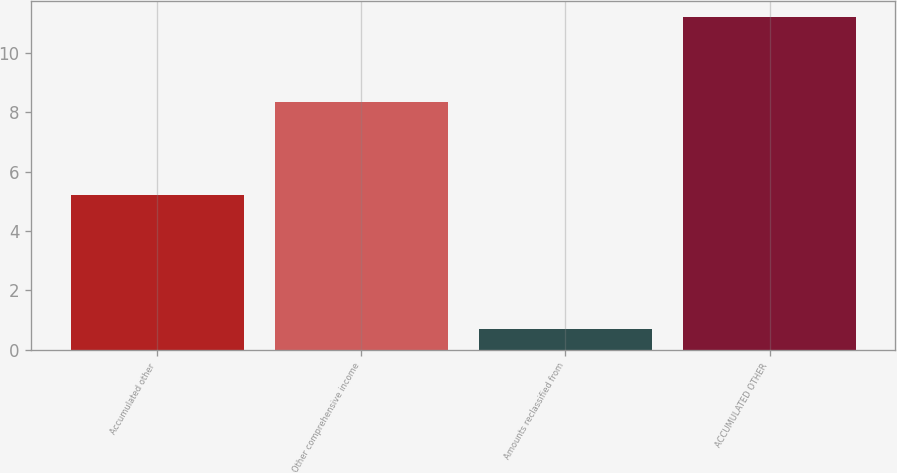<chart> <loc_0><loc_0><loc_500><loc_500><bar_chart><fcel>Accumulated other<fcel>Other comprehensive income<fcel>Amounts reclassified from<fcel>ACCUMULATED OTHER<nl><fcel>5.2<fcel>8.35<fcel>0.7<fcel>11.2<nl></chart> 